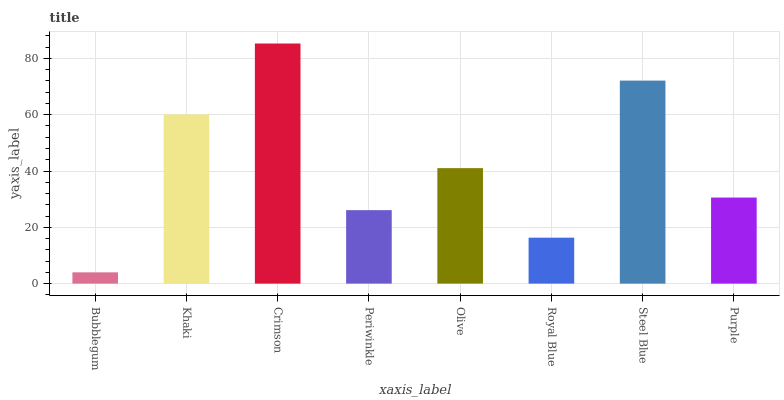Is Bubblegum the minimum?
Answer yes or no. Yes. Is Crimson the maximum?
Answer yes or no. Yes. Is Khaki the minimum?
Answer yes or no. No. Is Khaki the maximum?
Answer yes or no. No. Is Khaki greater than Bubblegum?
Answer yes or no. Yes. Is Bubblegum less than Khaki?
Answer yes or no. Yes. Is Bubblegum greater than Khaki?
Answer yes or no. No. Is Khaki less than Bubblegum?
Answer yes or no. No. Is Olive the high median?
Answer yes or no. Yes. Is Purple the low median?
Answer yes or no. Yes. Is Bubblegum the high median?
Answer yes or no. No. Is Bubblegum the low median?
Answer yes or no. No. 